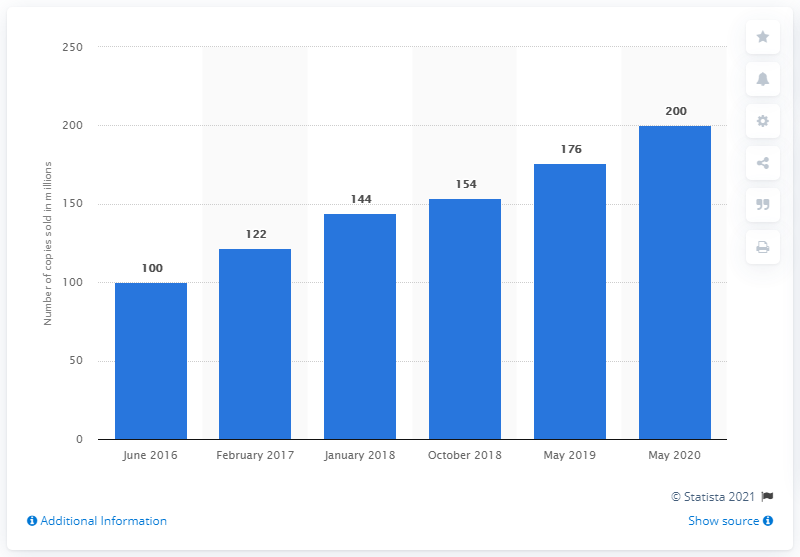Highlight a few significant elements in this photo. As of its release in 2011, Minecraft has sold over 200 million units worldwide. 